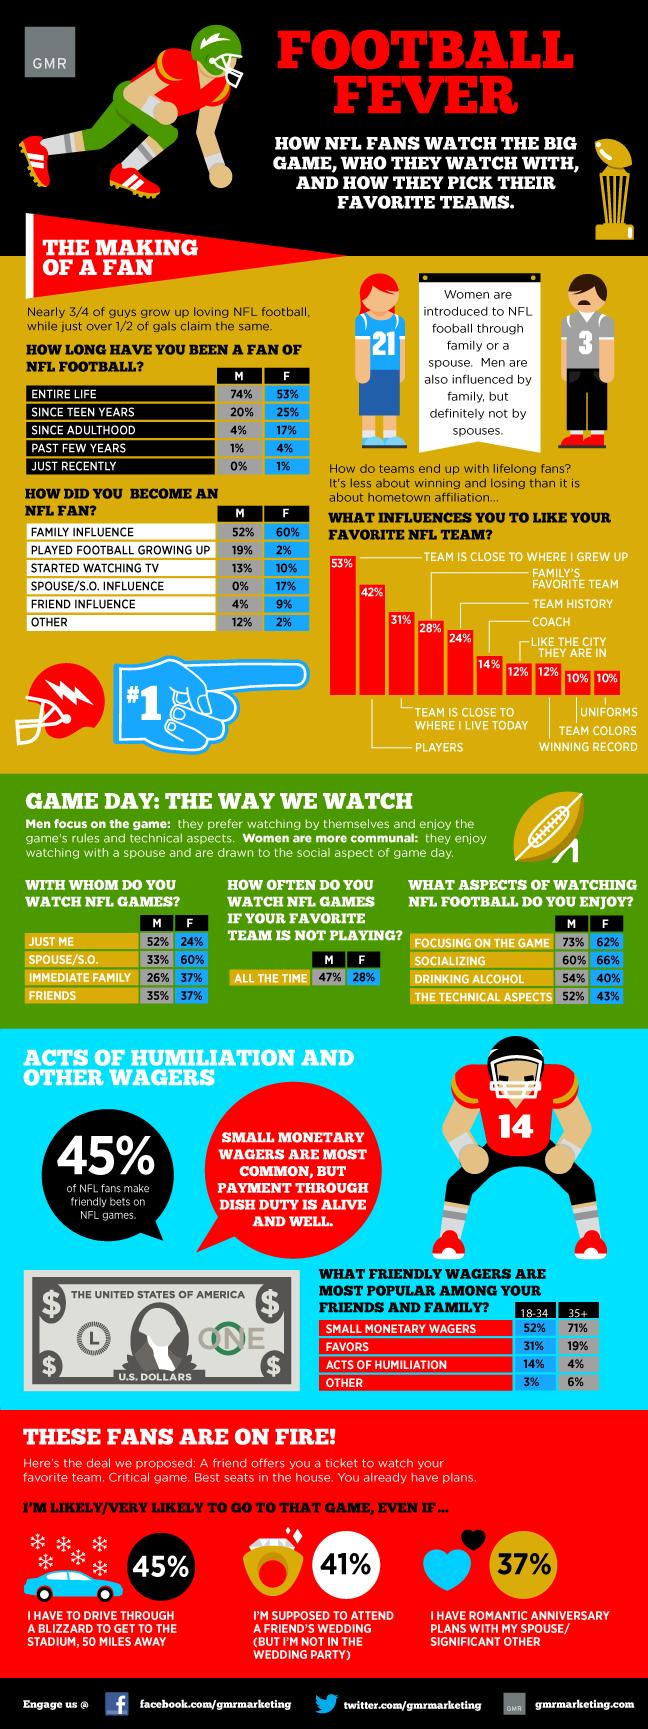Point out several critical features in this image. Winning records of an NFL team and the city in which they are located are both factors that can equally influence a person's liking of their favorite team. It is more likely for males to watch National Football League (NLF) games even if their favorite team is not playing, than for females. Approximately 20% of men (M) have been fans of NFL football since their teen years. According to the survey, having a spouse or partner does not have a significant impact on an individual's likelihood of becoming an NFL fan. It is more likely for a female to be influenced by their family to become an NFL fan than a male. 